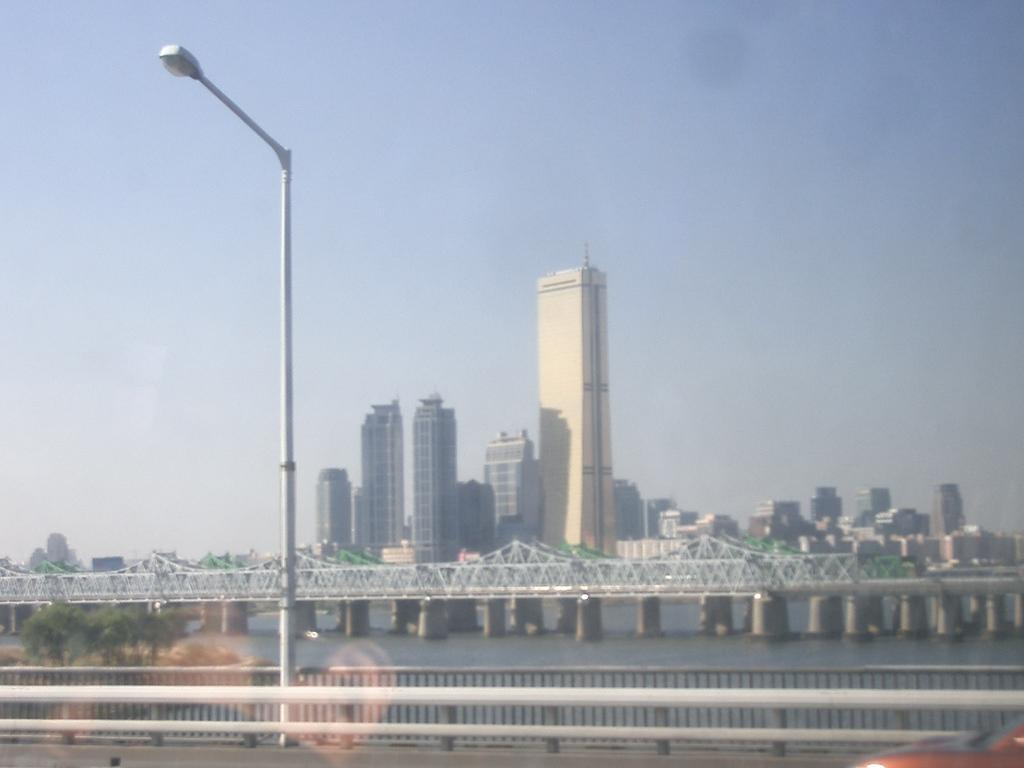What is on the pole in the image? There is a light on a pole in the image. What is behind the pole? There is a fence behind the pole. What type of vegetation can be seen in the image? Trees are visible in the image. What is the water feature in the image? There is water in the image. What can be seen in the background of the image? There is a bridge, buildings, and the sky visible in the background of the image. How many sisters are visible in the image? There are no sisters present in the image. Is there a zoo in the background of the image? There is no zoo present in the image. 